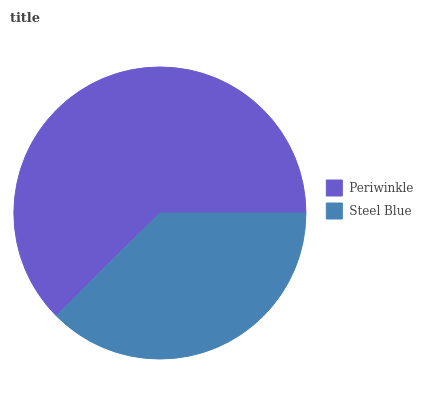Is Steel Blue the minimum?
Answer yes or no. Yes. Is Periwinkle the maximum?
Answer yes or no. Yes. Is Steel Blue the maximum?
Answer yes or no. No. Is Periwinkle greater than Steel Blue?
Answer yes or no. Yes. Is Steel Blue less than Periwinkle?
Answer yes or no. Yes. Is Steel Blue greater than Periwinkle?
Answer yes or no. No. Is Periwinkle less than Steel Blue?
Answer yes or no. No. Is Periwinkle the high median?
Answer yes or no. Yes. Is Steel Blue the low median?
Answer yes or no. Yes. Is Steel Blue the high median?
Answer yes or no. No. Is Periwinkle the low median?
Answer yes or no. No. 